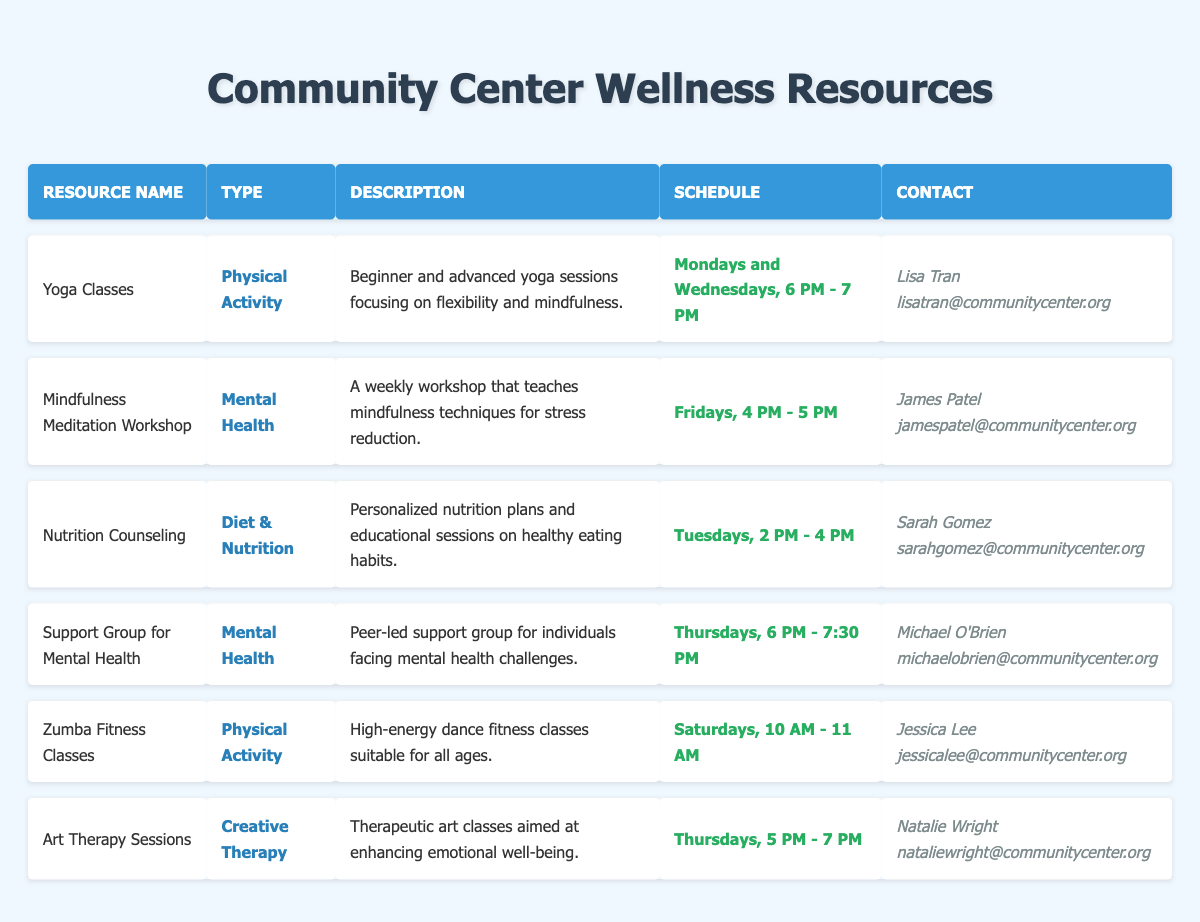What times are the Yoga Classes scheduled? The Yoga Classes are scheduled on Mondays and Wednesdays from 6 PM to 7 PM.
Answer: Mondays and Wednesdays, 6 PM - 7 PM Who conducts the Nutrition Counseling sessions? The Nutrition Counseling sessions are conducted by Sarah Gomez, as mentioned in the contact person column.
Answer: Sarah Gomez Is there a wellness resource focusing on Creative Therapy? Yes, there is an Art Therapy Session that focuses on enhancing emotional well-being, which falls under Creative Therapy.
Answer: Yes How many wellness resources are scheduled on Thursdays? There are two resources scheduled on Thursdays: the Support Group for Mental Health from 6 PM to 7:30 PM and Art Therapy Sessions from 5 PM to 7 PM.
Answer: 2 What are the types of resources available at the community center? The types of resources mentioned in the table are Physical Activity, Mental Health, Diet & Nutrition, and Creative Therapy. These can be retrieved by looking at the resource type column for all entries.
Answer: Physical Activity, Mental Health, Diet & Nutrition, Creative Therapy Which resource has the latest schedule on Fridays? The Mindfulness Meditation Workshop is the only resource scheduled on Fridays from 4 PM to 5 PM, making it the latest by time on that day.
Answer: Mindfulness Meditation Workshop Are there more physical activity classes or mental health resources available? There are three Physical Activity resources (Yoga Classes, Zumba Fitness Classes) and three Mental Health resources (Mindfulness Meditation Workshop, Support Group for Mental Health), making them equal in quantity.
Answer: Equal What is the contact email for the instructor of the Zumba Fitness Classes? The contact email for Zumba Fitness Classes is listed under Jessica Lee in the contact email column, which is jessicalee@communitycenter.org.
Answer: jessicalee@communitycenter.org What type of resource focuses on stress reduction techniques? The Mindfulness Meditation Workshop focuses on mindfulness techniques for stress reduction, as stated in its description.
Answer: Mindfulness Meditation Workshop 